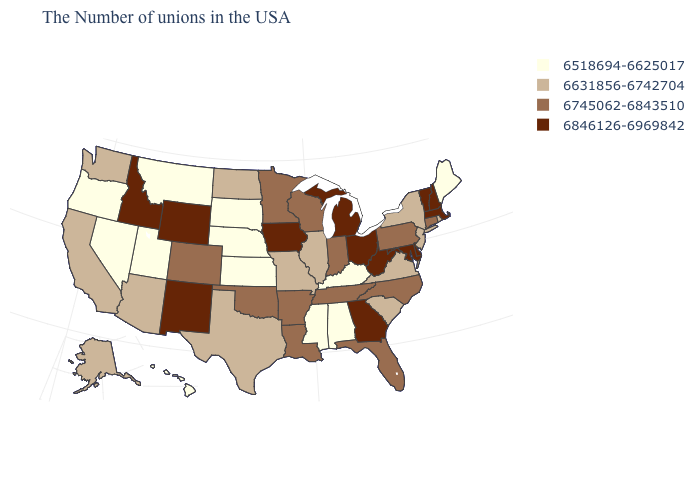Name the states that have a value in the range 6518694-6625017?
Be succinct. Maine, Kentucky, Alabama, Mississippi, Kansas, Nebraska, South Dakota, Utah, Montana, Nevada, Oregon, Hawaii. What is the value of Florida?
Short answer required. 6745062-6843510. What is the highest value in the USA?
Short answer required. 6846126-6969842. What is the value of Kentucky?
Answer briefly. 6518694-6625017. Name the states that have a value in the range 6631856-6742704?
Concise answer only. Rhode Island, New York, New Jersey, Virginia, South Carolina, Illinois, Missouri, Texas, North Dakota, Arizona, California, Washington, Alaska. Does the map have missing data?
Be succinct. No. Does Colorado have the lowest value in the USA?
Be succinct. No. Name the states that have a value in the range 6631856-6742704?
Write a very short answer. Rhode Island, New York, New Jersey, Virginia, South Carolina, Illinois, Missouri, Texas, North Dakota, Arizona, California, Washington, Alaska. What is the value of Kansas?
Answer briefly. 6518694-6625017. What is the value of Illinois?
Write a very short answer. 6631856-6742704. Name the states that have a value in the range 6846126-6969842?
Concise answer only. Massachusetts, New Hampshire, Vermont, Delaware, Maryland, West Virginia, Ohio, Georgia, Michigan, Iowa, Wyoming, New Mexico, Idaho. Name the states that have a value in the range 6745062-6843510?
Write a very short answer. Connecticut, Pennsylvania, North Carolina, Florida, Indiana, Tennessee, Wisconsin, Louisiana, Arkansas, Minnesota, Oklahoma, Colorado. Name the states that have a value in the range 6631856-6742704?
Quick response, please. Rhode Island, New York, New Jersey, Virginia, South Carolina, Illinois, Missouri, Texas, North Dakota, Arizona, California, Washington, Alaska. Name the states that have a value in the range 6518694-6625017?
Short answer required. Maine, Kentucky, Alabama, Mississippi, Kansas, Nebraska, South Dakota, Utah, Montana, Nevada, Oregon, Hawaii. What is the value of South Carolina?
Give a very brief answer. 6631856-6742704. 